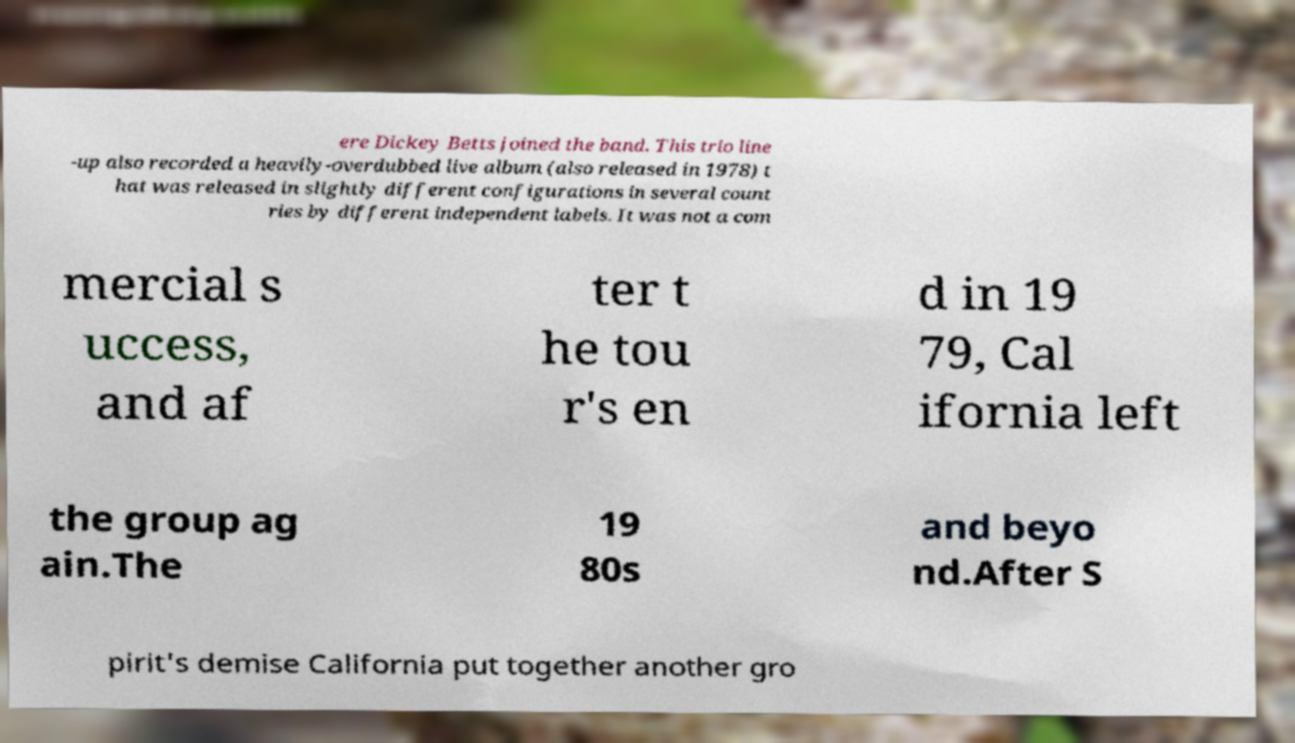Can you accurately transcribe the text from the provided image for me? ere Dickey Betts joined the band. This trio line -up also recorded a heavily-overdubbed live album (also released in 1978) t hat was released in slightly different configurations in several count ries by different independent labels. It was not a com mercial s uccess, and af ter t he tou r's en d in 19 79, Cal ifornia left the group ag ain.The 19 80s and beyo nd.After S pirit's demise California put together another gro 